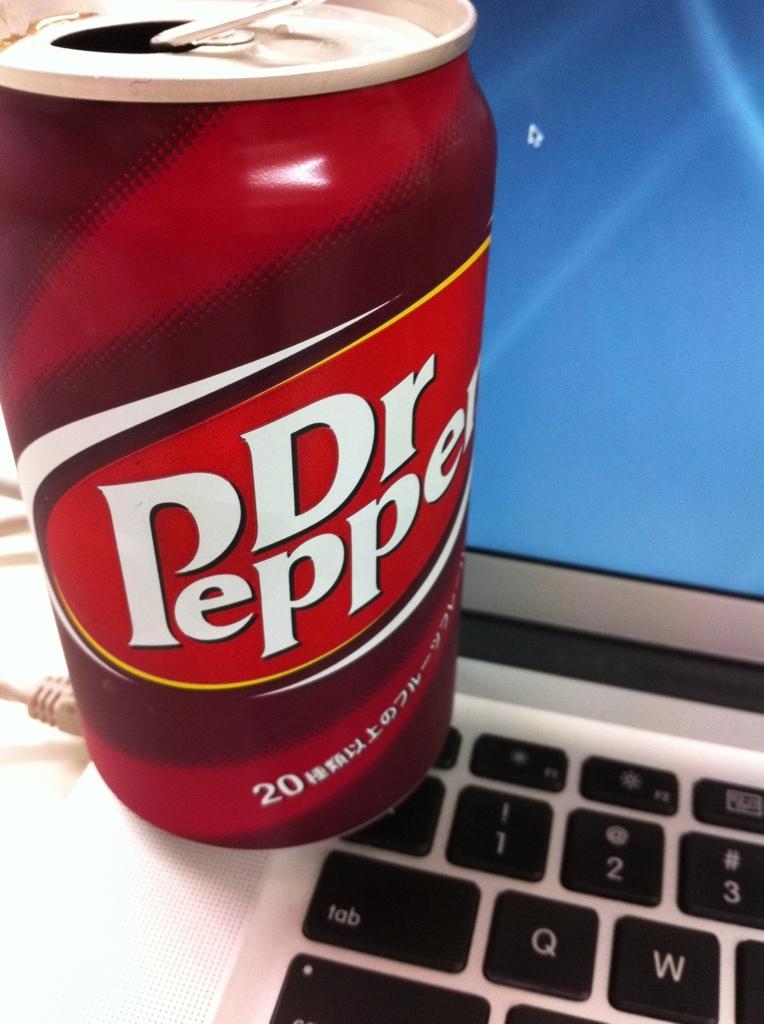What is the name on the drink?
Provide a short and direct response. Dr pepper. 